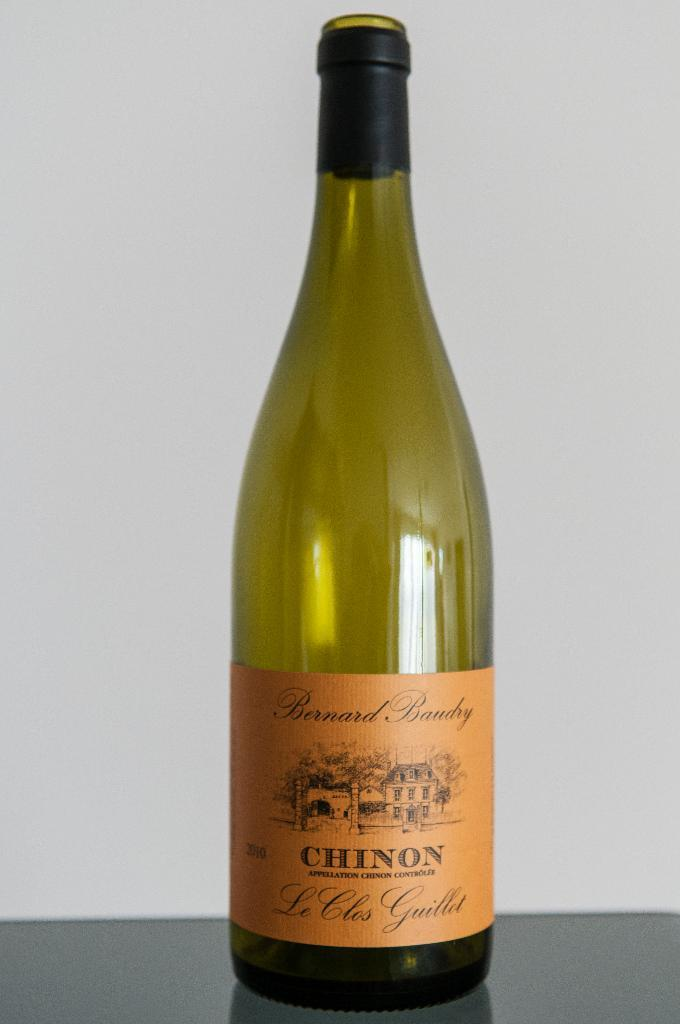Provide a one-sentence caption for the provided image. An empty bottle of Chinon wine sits on a table. 